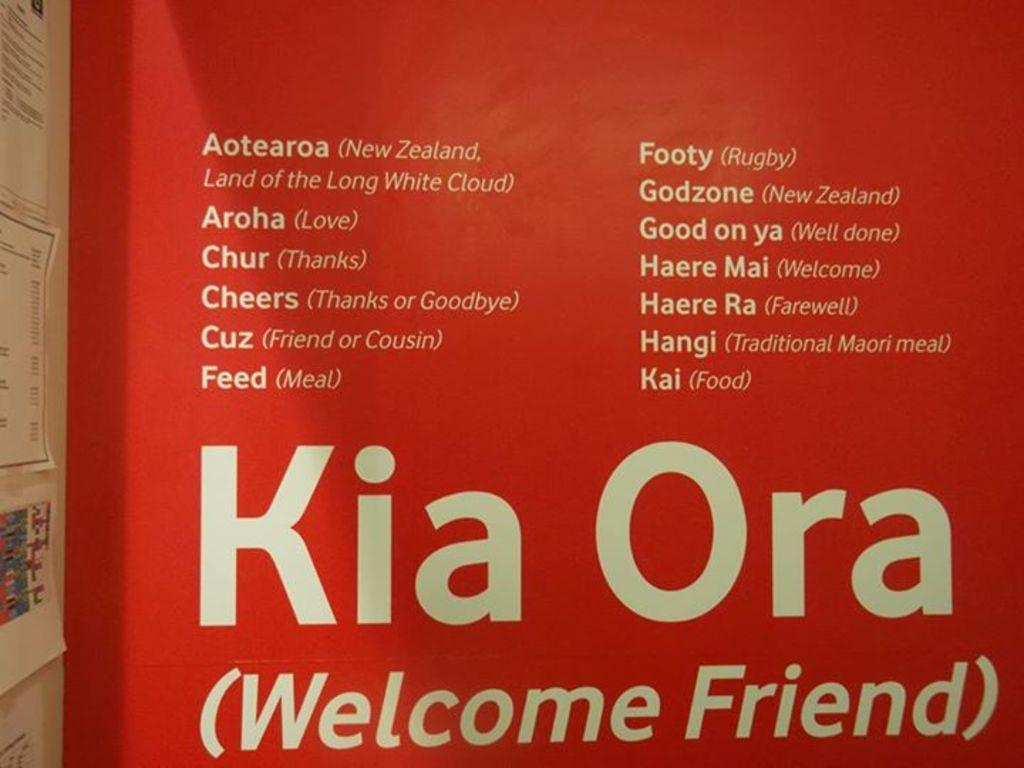Provide a one-sentence caption for the provided image. Kia Ora (Welcom Friend) sign on a rad background. 